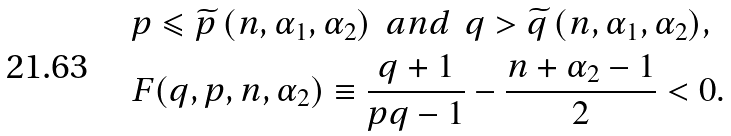Convert formula to latex. <formula><loc_0><loc_0><loc_500><loc_500>& p \leqslant \widetilde { p } \, ( n , \alpha _ { 1 } , \alpha _ { 2 } ) \ \ a n d \ \ q > \widetilde { q } \, ( n , \alpha _ { 1 } , \alpha _ { 2 } ) , \\ & F ( q , p , n , \alpha _ { 2 } ) \equiv \frac { q + 1 } { p q - 1 } - \frac { n + \alpha _ { 2 } - 1 } { 2 } < 0 .</formula> 